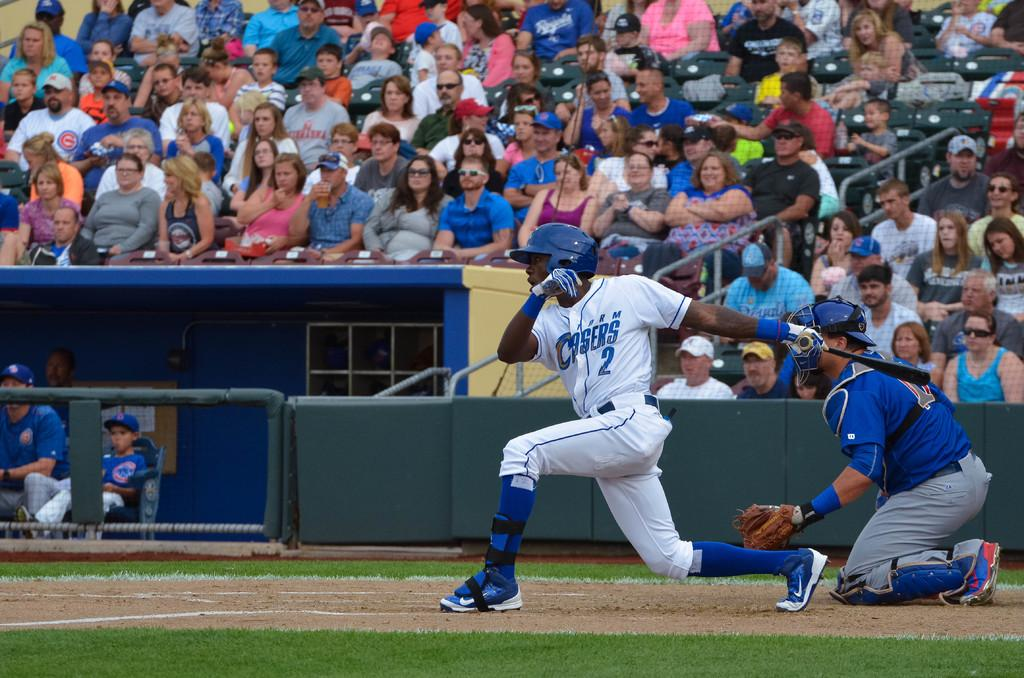<image>
Present a compact description of the photo's key features. Baseball player for Casers about to hit the ball. 